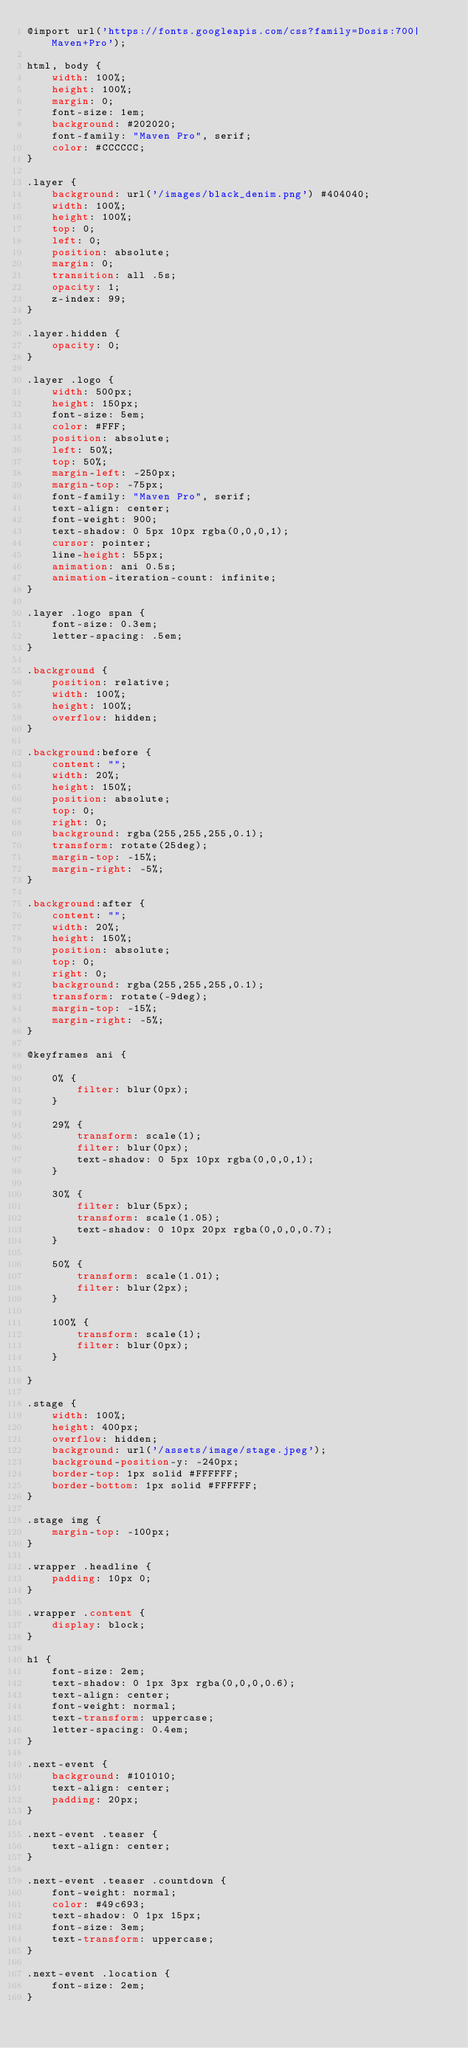Convert code to text. <code><loc_0><loc_0><loc_500><loc_500><_CSS_>@import url('https://fonts.googleapis.com/css?family=Dosis:700|Maven+Pro');

html, body {
    width: 100%;
    height: 100%;
    margin: 0;
    font-size: 1em;
    background: #202020;
    font-family: "Maven Pro", serif;
    color: #CCCCCC;
}

.layer {
    background: url('/images/black_denim.png') #404040;
    width: 100%;
    height: 100%;
    top: 0;
    left: 0;
    position: absolute;
    margin: 0;
    transition: all .5s;
    opacity: 1;
    z-index: 99;
}

.layer.hidden {
    opacity: 0;
}

.layer .logo {
    width: 500px;
    height: 150px;
    font-size: 5em;
    color: #FFF;
    position: absolute;
    left: 50%;
    top: 50%;
    margin-left: -250px;
    margin-top: -75px;
    font-family: "Maven Pro", serif;
    text-align: center;
    font-weight: 900;
    text-shadow: 0 5px 10px rgba(0,0,0,1);
    cursor: pointer;
    line-height: 55px;
    animation: ani 0.5s;
    animation-iteration-count: infinite;
}

.layer .logo span {
    font-size: 0.3em;
    letter-spacing: .5em;
}

.background {
    position: relative;
    width: 100%;
    height: 100%;
    overflow: hidden;
}

.background:before {
    content: "";
    width: 20%;
    height: 150%;
    position: absolute;
    top: 0;
    right: 0;
    background: rgba(255,255,255,0.1);
    transform: rotate(25deg);
    margin-top: -15%;
    margin-right: -5%;
}

.background:after {
    content: "";
    width: 20%;
    height: 150%;
    position: absolute;
    top: 0;
    right: 0;
    background: rgba(255,255,255,0.1);
    transform: rotate(-9deg);
    margin-top: -15%;
    margin-right: -5%;
}

@keyframes ani {

    0% {
        filter: blur(0px);
    }

    29% {
        transform: scale(1);
        filter: blur(0px);
        text-shadow: 0 5px 10px rgba(0,0,0,1);
    }

    30% {
        filter: blur(5px);
        transform: scale(1.05);
        text-shadow: 0 10px 20px rgba(0,0,0,0.7);
    }

    50% {
        transform: scale(1.01);
        filter: blur(2px);
    }

    100% {
        transform: scale(1);
        filter: blur(0px);
    }

}

.stage {
    width: 100%;
    height: 400px;
    overflow: hidden;
    background: url('/assets/image/stage.jpeg');
    background-position-y: -240px;
    border-top: 1px solid #FFFFFF;
    border-bottom: 1px solid #FFFFFF;
}

.stage img {
    margin-top: -100px;
}

.wrapper .headline {
    padding: 10px 0;
}

.wrapper .content {
    display: block;
}

h1 {
    font-size: 2em;
    text-shadow: 0 1px 3px rgba(0,0,0,0.6);
    text-align: center;
    font-weight: normal;
    text-transform: uppercase;
    letter-spacing: 0.4em;
}

.next-event {
    background: #101010;
    text-align: center;
    padding: 20px;
}

.next-event .teaser {
    text-align: center;
}

.next-event .teaser .countdown {
    font-weight: normal;
    color: #49c693;
    text-shadow: 0 1px 15px;
    font-size: 3em;
    text-transform: uppercase;
}

.next-event .location {
    font-size: 2em;
}</code> 